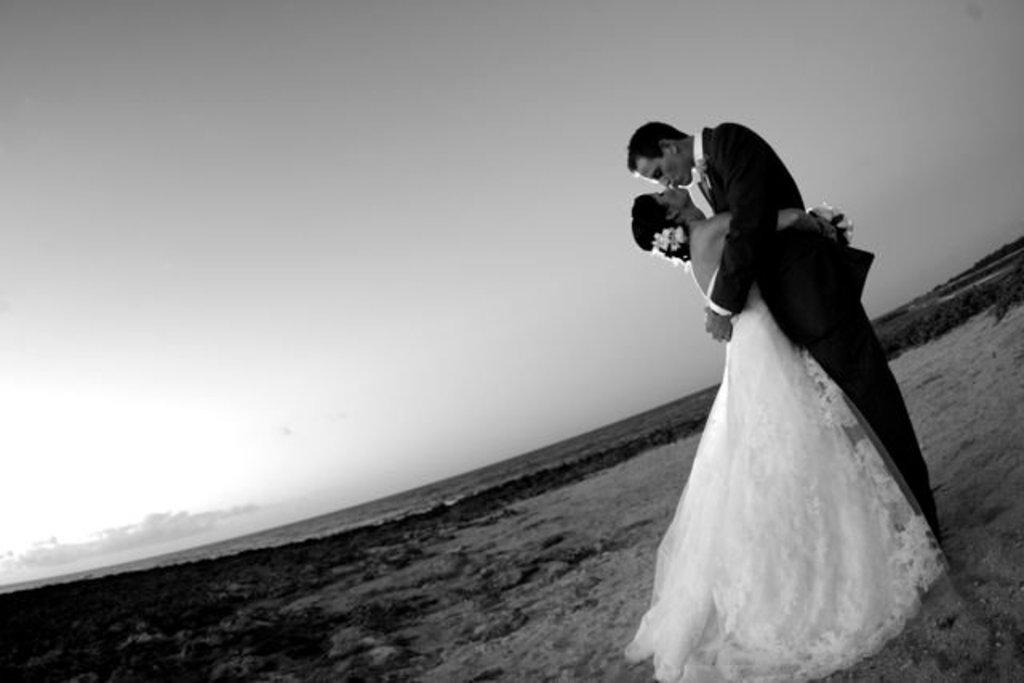What are the people in the image doing? The persons standing in the front of the image are hugging each other. What type of ground is visible in the background of the image? There is grass on the ground in the background of the image. What is the condition of the sky in the image? The sky is cloudy in the background of the image. What type of cooking system is visible in the image? There is no cooking system present in the image. How do the persons in the image join together? The persons in the image are already hugging each other, so they are already joined together. 